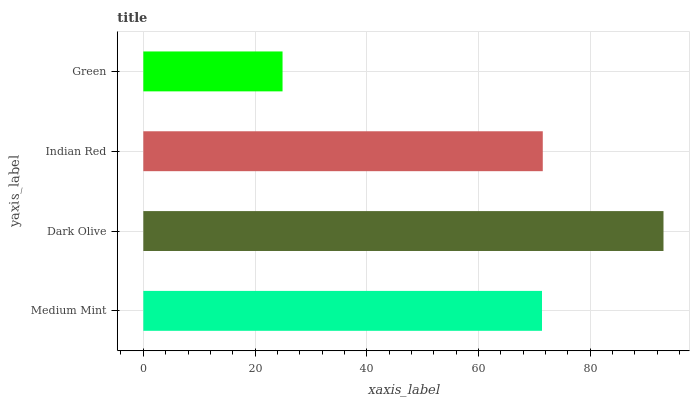Is Green the minimum?
Answer yes or no. Yes. Is Dark Olive the maximum?
Answer yes or no. Yes. Is Indian Red the minimum?
Answer yes or no. No. Is Indian Red the maximum?
Answer yes or no. No. Is Dark Olive greater than Indian Red?
Answer yes or no. Yes. Is Indian Red less than Dark Olive?
Answer yes or no. Yes. Is Indian Red greater than Dark Olive?
Answer yes or no. No. Is Dark Olive less than Indian Red?
Answer yes or no. No. Is Indian Red the high median?
Answer yes or no. Yes. Is Medium Mint the low median?
Answer yes or no. Yes. Is Medium Mint the high median?
Answer yes or no. No. Is Indian Red the low median?
Answer yes or no. No. 